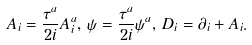Convert formula to latex. <formula><loc_0><loc_0><loc_500><loc_500>A _ { i } = \frac { \tau ^ { a } } { 2 i } A _ { i } ^ { a } , \, \psi = \frac { \tau ^ { a } } { 2 i } \psi ^ { a } , \, D _ { i } = \partial _ { i } + A _ { i } .</formula> 